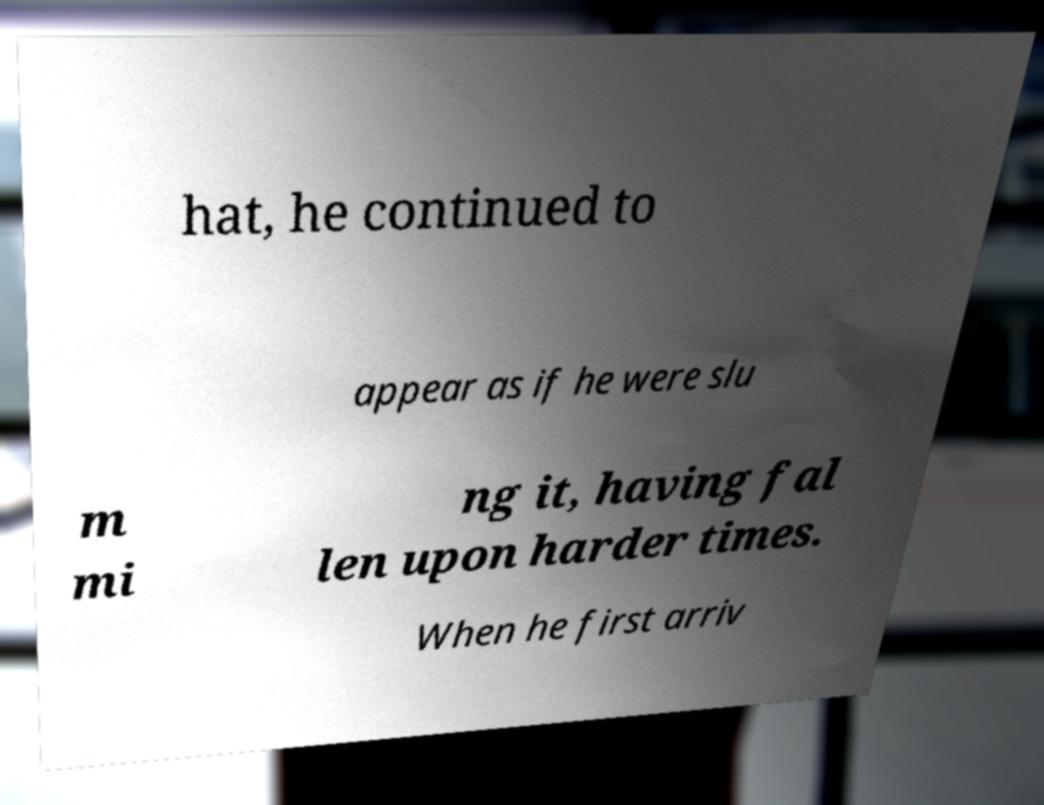Please identify and transcribe the text found in this image. hat, he continued to appear as if he were slu m mi ng it, having fal len upon harder times. When he first arriv 